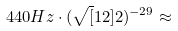<formula> <loc_0><loc_0><loc_500><loc_500>4 4 0 H z \cdot ( \sqrt { [ } 1 2 ] { 2 } ) ^ { - 2 9 } \approx</formula> 